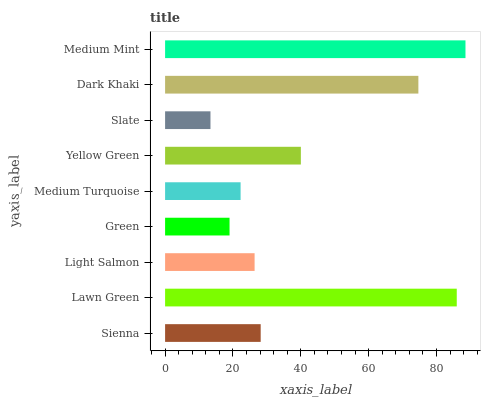Is Slate the minimum?
Answer yes or no. Yes. Is Medium Mint the maximum?
Answer yes or no. Yes. Is Lawn Green the minimum?
Answer yes or no. No. Is Lawn Green the maximum?
Answer yes or no. No. Is Lawn Green greater than Sienna?
Answer yes or no. Yes. Is Sienna less than Lawn Green?
Answer yes or no. Yes. Is Sienna greater than Lawn Green?
Answer yes or no. No. Is Lawn Green less than Sienna?
Answer yes or no. No. Is Sienna the high median?
Answer yes or no. Yes. Is Sienna the low median?
Answer yes or no. Yes. Is Medium Turquoise the high median?
Answer yes or no. No. Is Light Salmon the low median?
Answer yes or no. No. 